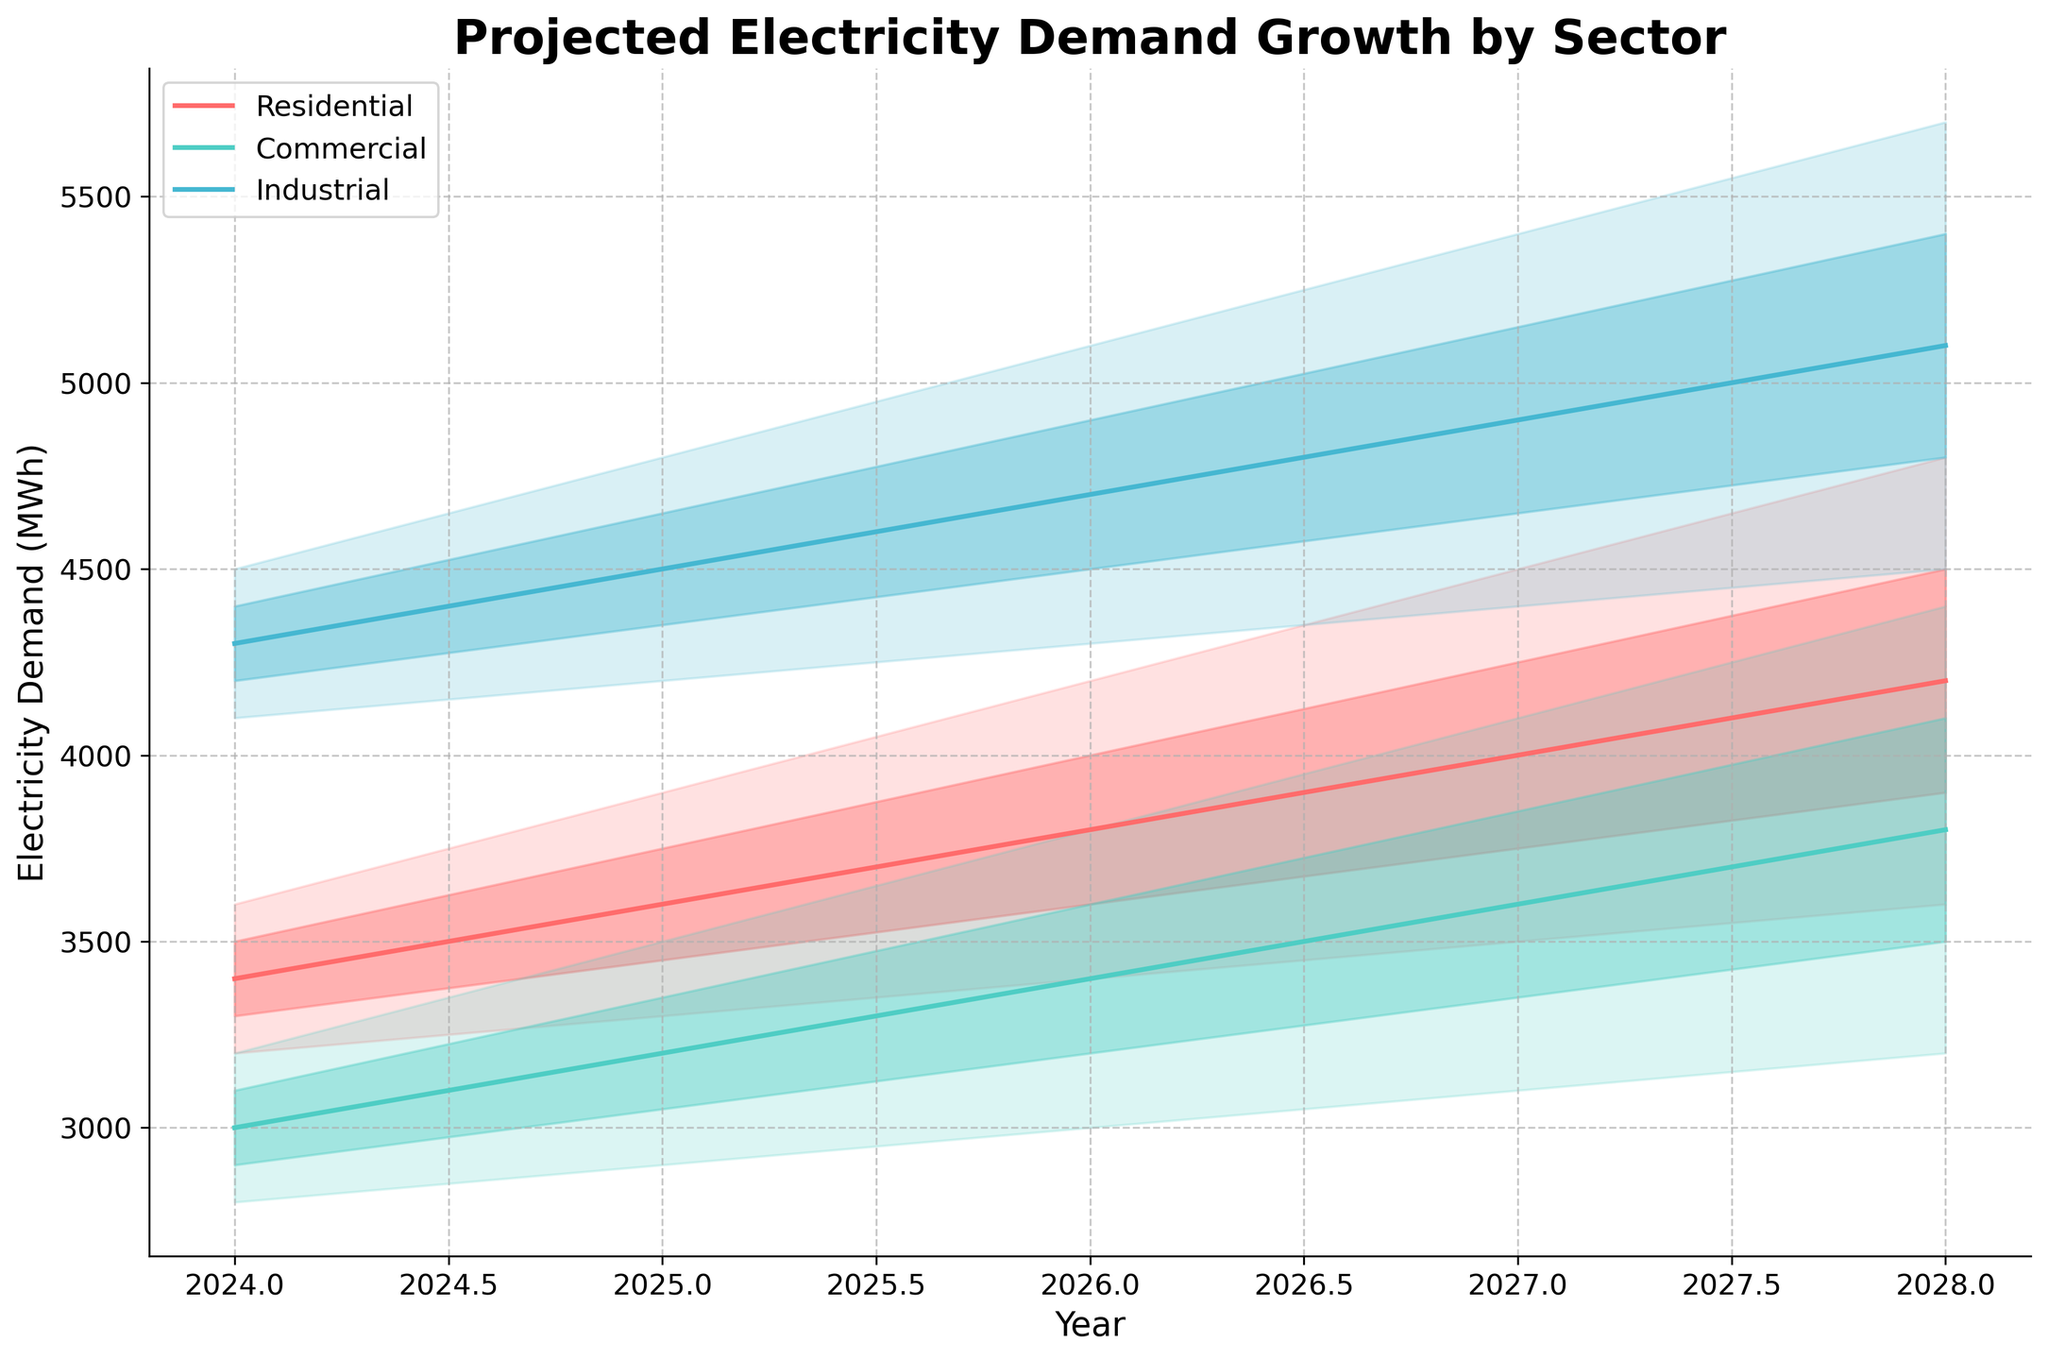What is the title of the figure? The title is usually displayed prominently at the top of the figure. In this case, it reads "Projected Electricity Demand Growth by Sector."
Answer: Projected Electricity Demand Growth by Sector Which sector has the highest median electricity demand in 2024? To find the highest median value for 2024, compare the median lines for each sector. The industrial sector shows a median electricity demand of 4300 MWh, which is the highest among the sectors.
Answer: Industrial What is the range of projected electricity demand for the residential sector in 2028? For 2028, the lower bound is given by "Lower10" at 3600 MWh and the upper bound by "Upper90" at 4800 MWh. The range is calculated by subtracting the lower bound from the upper bound: 4800 - 3600.
Answer: 1200 MWh How does the projected electricity demand for the commercial sector in 2026 compare to the residential sector in the same year? In 2026, the median value for the commercial sector is 3400 MWh, and for the residential sector, it is 3800 MWh. The commercial sector's demand is lower.
Answer: The commercial sector's demand is lower What is the trend for the industrial sector's projected electricity demand from 2024 to 2028? By observing the median line for the industrial sector, the trend shows a consistent increase from 4300 MWh in 2024 to 5100 MWh in 2028.
Answer: Increasing trend If you average the median electricity demands for the residential sector across all the years, what value do you get? Sum of median values: (3400 + 3600 + 3800 + 4000 + 4200) = 19000 MWh. Average is 19000/5.
Answer: 3800 MWh Which sector shows the largest uncertainty in projections for the year 2027? Uncertainty can be measured by the difference between the Upper90 and Lower10 values. For 2027, these differences are: Residential (4500 - 3500 = 1000 MWh), Commercial (4100 - 3100 = 1000 MWh), and Industrial (5400 - 4400 = 1000 MWh). All sectors have the same level of uncertainty.
Answer: All sectors What can you infer about the relative increase in electricity demand between the residential and industrial sectors from 2024 to 2028? For the residential sector, the median values increase from 3400 MWh to 4200 MWh, a rise of 800 MWh. For the industrial sector, the median values increase from 4300 MWh to 5100 MWh, a rise of 800 MWh. Both sectors have the same absolute increase in demand.
Answer: Same increase Between which years does the commercial sector show the highest increase in its median electricity demand? To find this, look at the median values and calculate the differences year by year. The largest increase is from 2027 (3600 MWh) to 2028 (3800 MWh), an increase of 200 MWh.
Answer: 2027 to 2028 